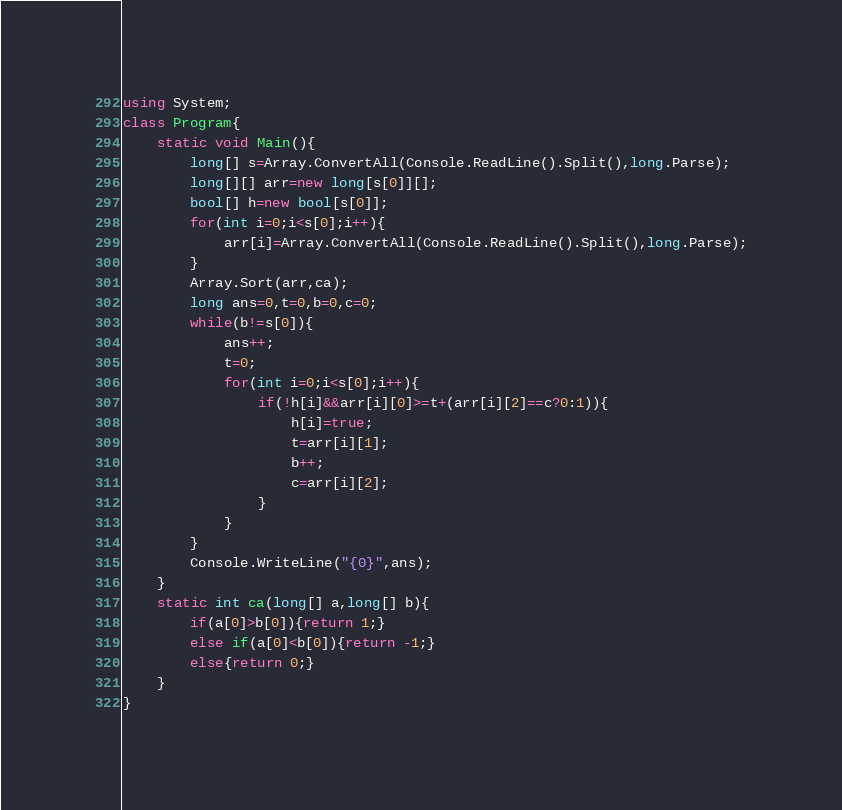<code> <loc_0><loc_0><loc_500><loc_500><_C#_>using System;
class Program{
	static void Main(){
		long[] s=Array.ConvertAll(Console.ReadLine().Split(),long.Parse);
		long[][] arr=new long[s[0]][];
		bool[] h=new bool[s[0]];
		for(int i=0;i<s[0];i++){
			arr[i]=Array.ConvertAll(Console.ReadLine().Split(),long.Parse);
		}
		Array.Sort(arr,ca);
		long ans=0,t=0,b=0,c=0;
		while(b!=s[0]){
			ans++;
			t=0;
			for(int i=0;i<s[0];i++){
				if(!h[i]&&arr[i][0]>=t+(arr[i][2]==c?0:1)){
					h[i]=true;
					t=arr[i][1];
					b++;
					c=arr[i][2];
				}
			}
		}
		Console.WriteLine("{0}",ans);
	}
	static int ca(long[] a,long[] b){
		if(a[0]>b[0]){return 1;}
		else if(a[0]<b[0]){return -1;}
		else{return 0;}
	}
}</code> 